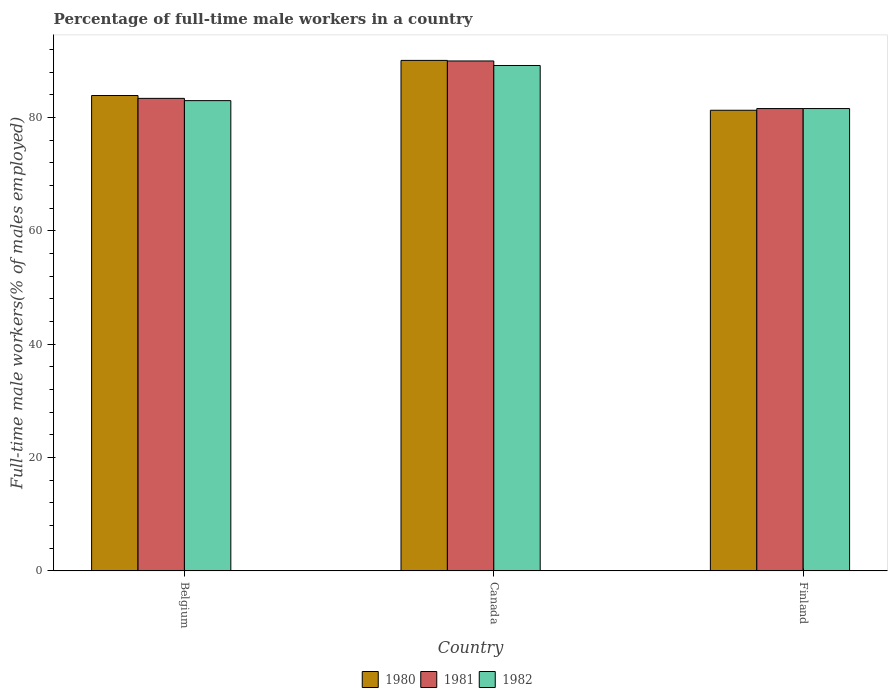How many different coloured bars are there?
Make the answer very short. 3. Are the number of bars on each tick of the X-axis equal?
Ensure brevity in your answer.  Yes. How many bars are there on the 3rd tick from the left?
Your response must be concise. 3. What is the label of the 3rd group of bars from the left?
Provide a succinct answer. Finland. What is the percentage of full-time male workers in 1981 in Finland?
Make the answer very short. 81.6. Across all countries, what is the maximum percentage of full-time male workers in 1980?
Offer a terse response. 90.1. Across all countries, what is the minimum percentage of full-time male workers in 1982?
Ensure brevity in your answer.  81.6. In which country was the percentage of full-time male workers in 1981 minimum?
Provide a succinct answer. Finland. What is the total percentage of full-time male workers in 1982 in the graph?
Make the answer very short. 253.8. What is the difference between the percentage of full-time male workers in 1980 in Belgium and that in Finland?
Your answer should be very brief. 2.6. What is the difference between the percentage of full-time male workers in 1980 in Belgium and the percentage of full-time male workers in 1981 in Finland?
Provide a short and direct response. 2.3. What is the average percentage of full-time male workers in 1982 per country?
Offer a terse response. 84.6. What is the ratio of the percentage of full-time male workers in 1980 in Belgium to that in Canada?
Provide a short and direct response. 0.93. Is the percentage of full-time male workers in 1981 in Belgium less than that in Canada?
Make the answer very short. Yes. Is the difference between the percentage of full-time male workers in 1982 in Belgium and Finland greater than the difference between the percentage of full-time male workers in 1981 in Belgium and Finland?
Your answer should be compact. No. What is the difference between the highest and the second highest percentage of full-time male workers in 1981?
Provide a short and direct response. -8.4. What is the difference between the highest and the lowest percentage of full-time male workers in 1982?
Offer a very short reply. 7.6. Is the sum of the percentage of full-time male workers in 1980 in Belgium and Canada greater than the maximum percentage of full-time male workers in 1981 across all countries?
Provide a short and direct response. Yes. What does the 2nd bar from the left in Finland represents?
Give a very brief answer. 1981. Are all the bars in the graph horizontal?
Your response must be concise. No. What is the difference between two consecutive major ticks on the Y-axis?
Your answer should be compact. 20. Are the values on the major ticks of Y-axis written in scientific E-notation?
Offer a terse response. No. Does the graph contain any zero values?
Offer a terse response. No. How many legend labels are there?
Provide a succinct answer. 3. What is the title of the graph?
Offer a very short reply. Percentage of full-time male workers in a country. Does "1971" appear as one of the legend labels in the graph?
Your answer should be very brief. No. What is the label or title of the Y-axis?
Offer a very short reply. Full-time male workers(% of males employed). What is the Full-time male workers(% of males employed) in 1980 in Belgium?
Provide a short and direct response. 83.9. What is the Full-time male workers(% of males employed) in 1981 in Belgium?
Offer a terse response. 83.4. What is the Full-time male workers(% of males employed) of 1980 in Canada?
Your response must be concise. 90.1. What is the Full-time male workers(% of males employed) in 1982 in Canada?
Your response must be concise. 89.2. What is the Full-time male workers(% of males employed) in 1980 in Finland?
Make the answer very short. 81.3. What is the Full-time male workers(% of males employed) in 1981 in Finland?
Your answer should be very brief. 81.6. What is the Full-time male workers(% of males employed) of 1982 in Finland?
Ensure brevity in your answer.  81.6. Across all countries, what is the maximum Full-time male workers(% of males employed) of 1980?
Ensure brevity in your answer.  90.1. Across all countries, what is the maximum Full-time male workers(% of males employed) of 1981?
Provide a short and direct response. 90. Across all countries, what is the maximum Full-time male workers(% of males employed) of 1982?
Your response must be concise. 89.2. Across all countries, what is the minimum Full-time male workers(% of males employed) in 1980?
Your answer should be very brief. 81.3. Across all countries, what is the minimum Full-time male workers(% of males employed) in 1981?
Keep it short and to the point. 81.6. Across all countries, what is the minimum Full-time male workers(% of males employed) in 1982?
Your answer should be compact. 81.6. What is the total Full-time male workers(% of males employed) in 1980 in the graph?
Provide a short and direct response. 255.3. What is the total Full-time male workers(% of males employed) of 1981 in the graph?
Keep it short and to the point. 255. What is the total Full-time male workers(% of males employed) in 1982 in the graph?
Your response must be concise. 253.8. What is the difference between the Full-time male workers(% of males employed) of 1980 in Belgium and that in Canada?
Your answer should be very brief. -6.2. What is the difference between the Full-time male workers(% of males employed) in 1980 in Belgium and that in Finland?
Offer a terse response. 2.6. What is the difference between the Full-time male workers(% of males employed) in 1981 in Belgium and that in Finland?
Keep it short and to the point. 1.8. What is the difference between the Full-time male workers(% of males employed) of 1982 in Belgium and that in Finland?
Ensure brevity in your answer.  1.4. What is the difference between the Full-time male workers(% of males employed) of 1980 in Belgium and the Full-time male workers(% of males employed) of 1981 in Canada?
Offer a terse response. -6.1. What is the difference between the Full-time male workers(% of males employed) of 1980 in Belgium and the Full-time male workers(% of males employed) of 1981 in Finland?
Provide a succinct answer. 2.3. What is the difference between the Full-time male workers(% of males employed) in 1980 in Belgium and the Full-time male workers(% of males employed) in 1982 in Finland?
Offer a very short reply. 2.3. What is the difference between the Full-time male workers(% of males employed) in 1980 in Canada and the Full-time male workers(% of males employed) in 1981 in Finland?
Ensure brevity in your answer.  8.5. What is the difference between the Full-time male workers(% of males employed) of 1980 in Canada and the Full-time male workers(% of males employed) of 1982 in Finland?
Ensure brevity in your answer.  8.5. What is the average Full-time male workers(% of males employed) in 1980 per country?
Offer a terse response. 85.1. What is the average Full-time male workers(% of males employed) in 1981 per country?
Provide a succinct answer. 85. What is the average Full-time male workers(% of males employed) in 1982 per country?
Provide a short and direct response. 84.6. What is the difference between the Full-time male workers(% of males employed) in 1981 and Full-time male workers(% of males employed) in 1982 in Belgium?
Offer a terse response. 0.4. What is the difference between the Full-time male workers(% of males employed) in 1980 and Full-time male workers(% of males employed) in 1982 in Canada?
Ensure brevity in your answer.  0.9. What is the difference between the Full-time male workers(% of males employed) in 1981 and Full-time male workers(% of males employed) in 1982 in Canada?
Offer a terse response. 0.8. What is the ratio of the Full-time male workers(% of males employed) in 1980 in Belgium to that in Canada?
Your answer should be compact. 0.93. What is the ratio of the Full-time male workers(% of males employed) of 1981 in Belgium to that in Canada?
Provide a short and direct response. 0.93. What is the ratio of the Full-time male workers(% of males employed) of 1982 in Belgium to that in Canada?
Ensure brevity in your answer.  0.93. What is the ratio of the Full-time male workers(% of males employed) of 1980 in Belgium to that in Finland?
Provide a succinct answer. 1.03. What is the ratio of the Full-time male workers(% of males employed) in 1981 in Belgium to that in Finland?
Keep it short and to the point. 1.02. What is the ratio of the Full-time male workers(% of males employed) of 1982 in Belgium to that in Finland?
Offer a very short reply. 1.02. What is the ratio of the Full-time male workers(% of males employed) of 1980 in Canada to that in Finland?
Provide a short and direct response. 1.11. What is the ratio of the Full-time male workers(% of males employed) in 1981 in Canada to that in Finland?
Your answer should be compact. 1.1. What is the ratio of the Full-time male workers(% of males employed) of 1982 in Canada to that in Finland?
Give a very brief answer. 1.09. What is the difference between the highest and the lowest Full-time male workers(% of males employed) in 1980?
Offer a terse response. 8.8. What is the difference between the highest and the lowest Full-time male workers(% of males employed) of 1981?
Keep it short and to the point. 8.4. 